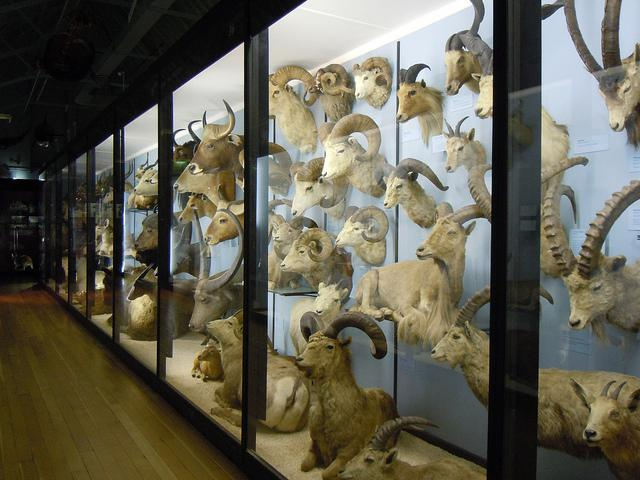What form of art was used to preserve these dead animals?

Choices:
A) taxidermy
B) metalworking
C) sculpting
D) drawing taxidermy 